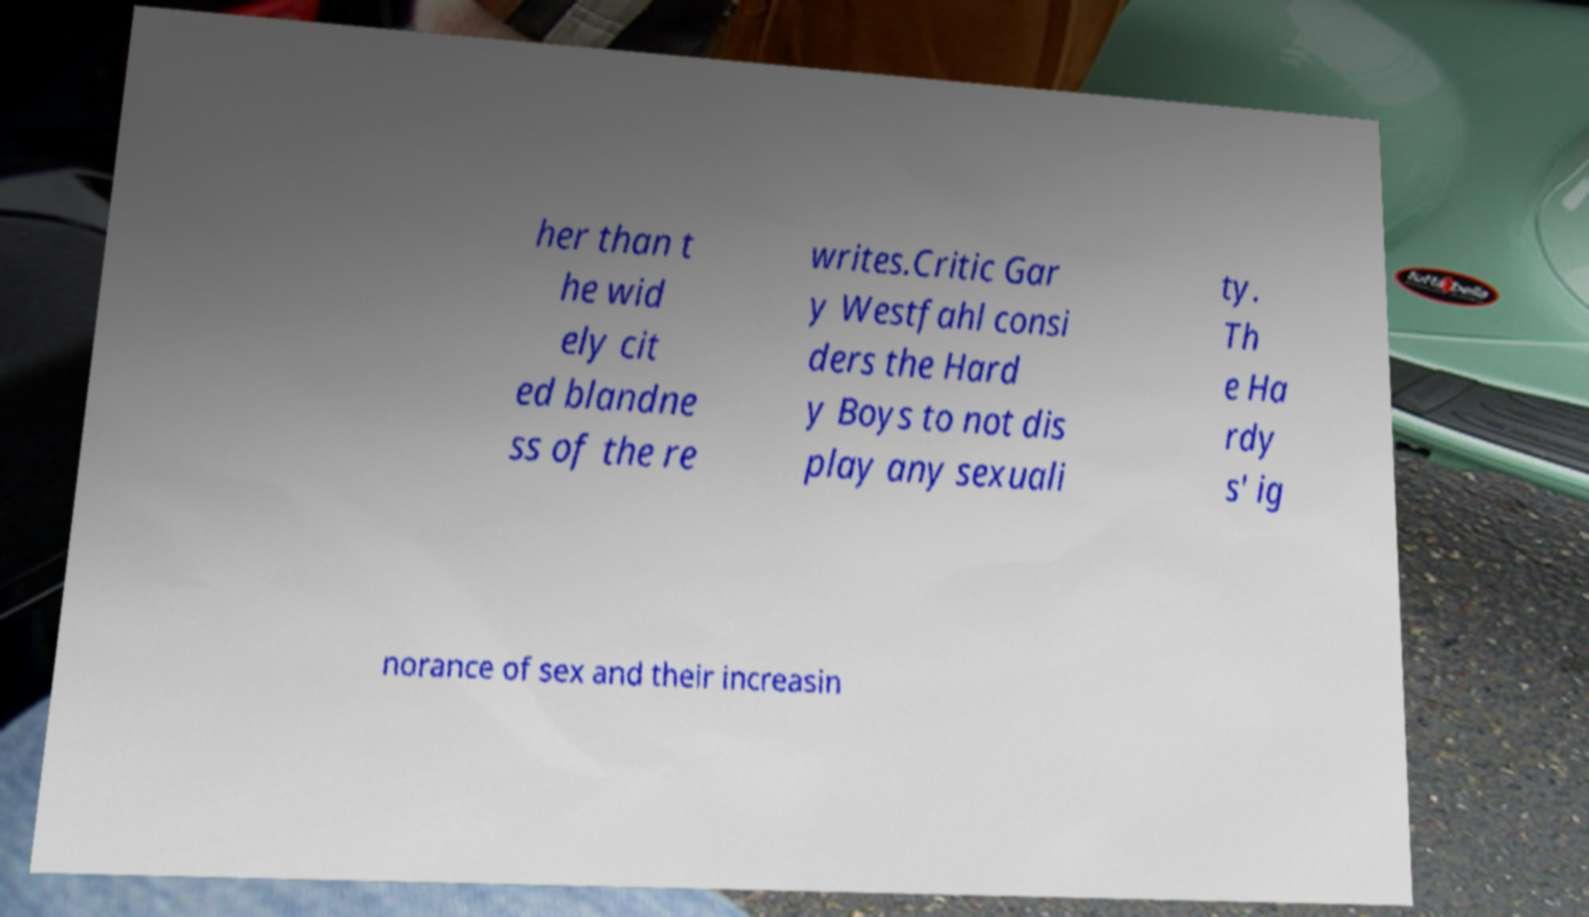Can you accurately transcribe the text from the provided image for me? her than t he wid ely cit ed blandne ss of the re writes.Critic Gar y Westfahl consi ders the Hard y Boys to not dis play any sexuali ty. Th e Ha rdy s' ig norance of sex and their increasin 